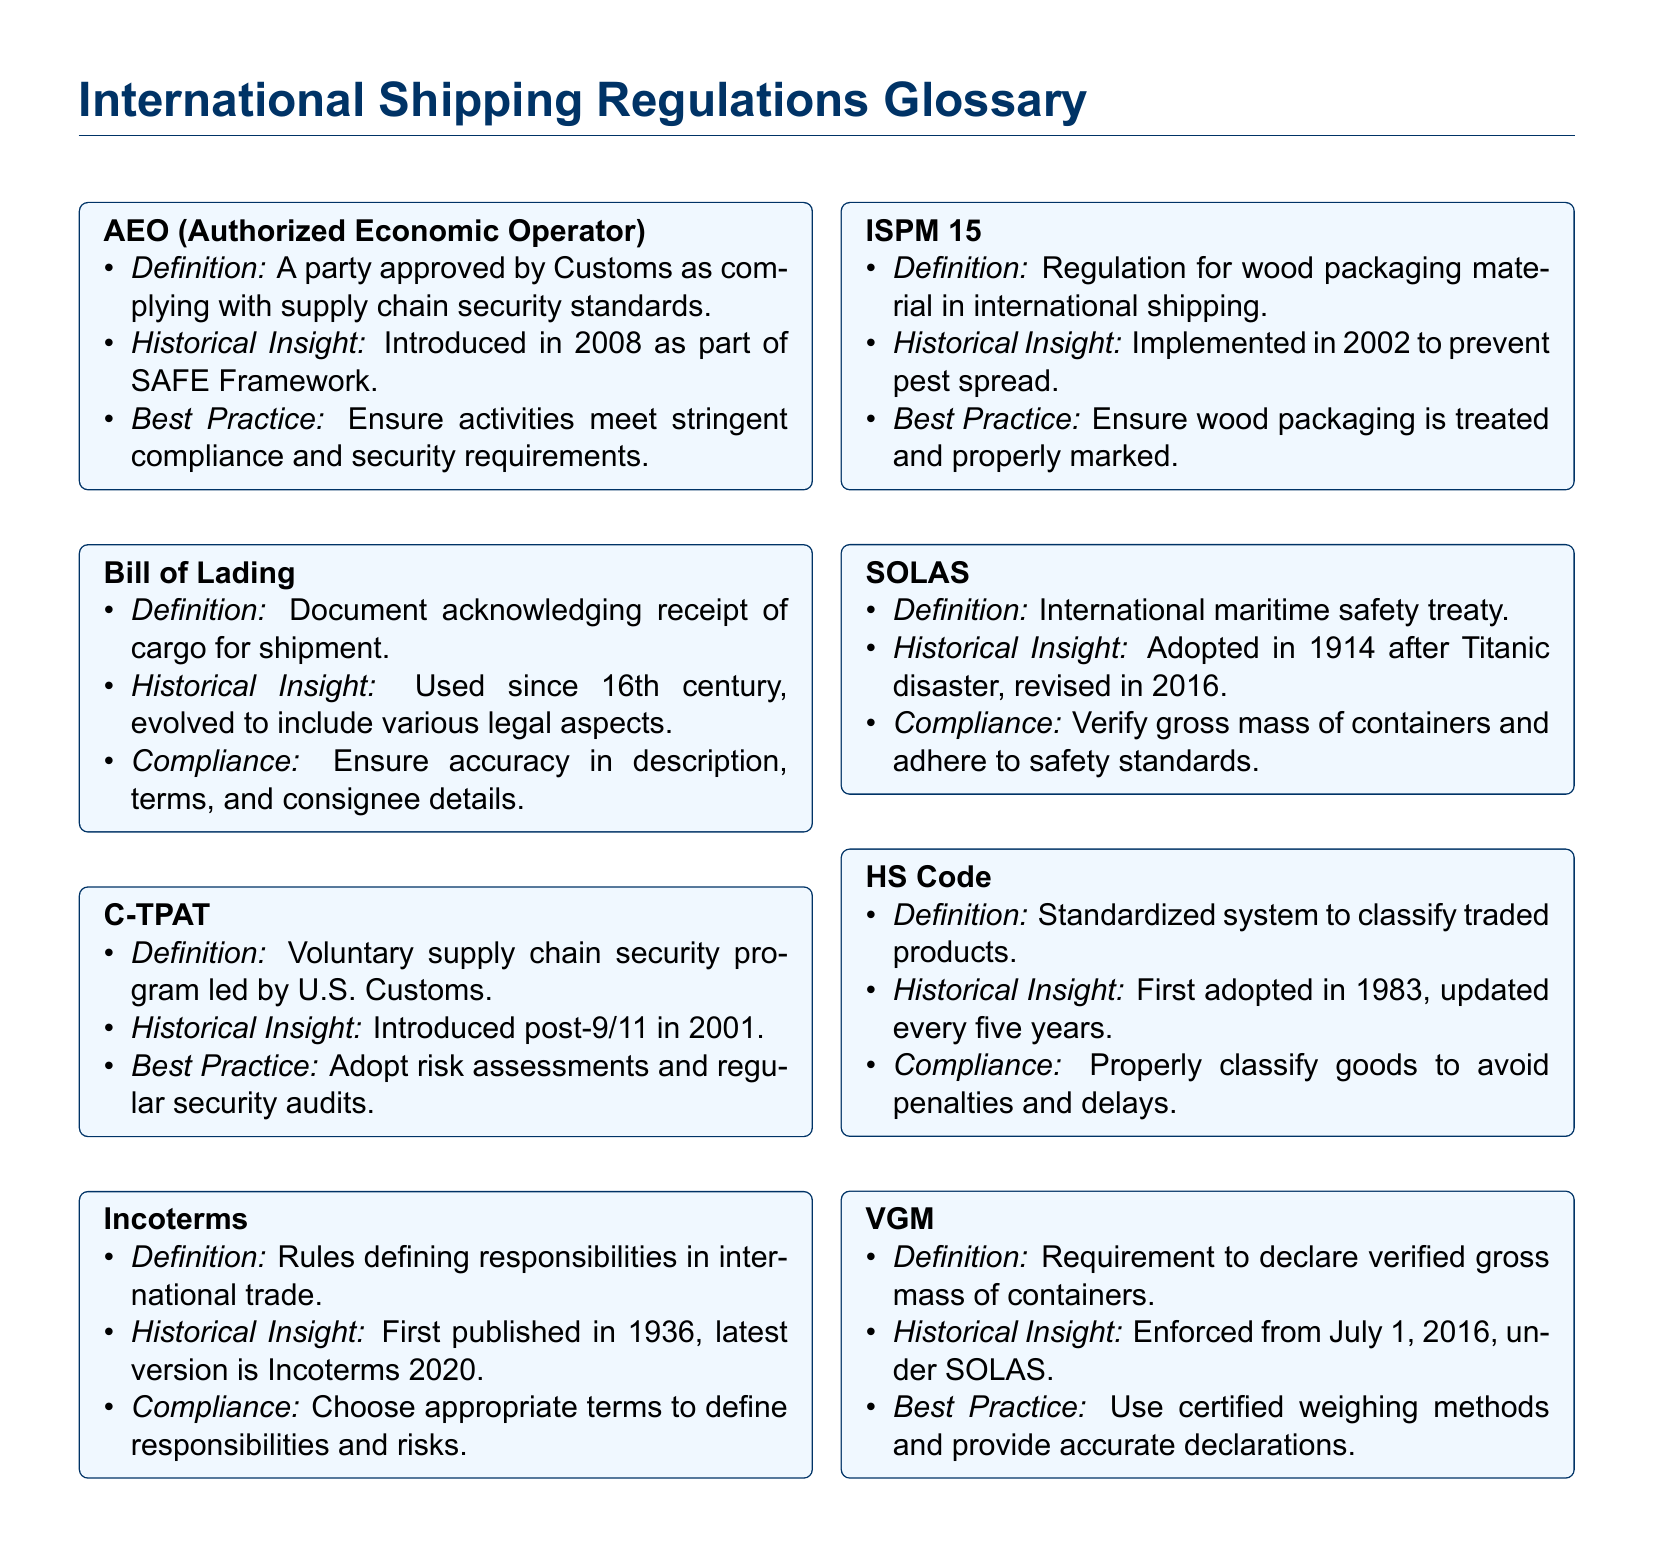What does AEO stand for? AEO stands for Authorized Economic Operator, which is defined in the document.
Answer: Authorized Economic Operator When was the Bill of Lading first used? The Bill of Lading was first used in the 16th century, as stated in the historical insight.
Answer: 16th century What year was C-TPAT introduced? The document specifies that C-TPAT was introduced in the year 2001 after the events of September 11.
Answer: 2001 What is the latest version of Incoterms? The document mentions that the latest version of Incoterms is from 2020.
Answer: Incoterms 2020 What does ISPM 15 regulate? ISPM 15 regulates wood packaging material in international shipping, according to the definition provided.
Answer: Wood packaging material When was SOLAS adopted? The document indicates that SOLAS was adopted in the year 1914.
Answer: 1914 What system does the HS Code refer to? HS Code refers to a standardized system for classifying traded products, clearly outlined in the definition.
Answer: Classify traded products What is the requirement of VGM? The requirement of VGM is to declare the verified gross mass of containers, as stated in the document.
Answer: Verified gross mass of containers What historical event prompted the introduction of C-TPAT? The historical insight in the document notes that C-TPAT was introduced post-9/11.
Answer: Post-9/11 